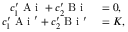<formula> <loc_0><loc_0><loc_500><loc_500>\begin{array} { r l } { c _ { 1 } ^ { \prime } A i + c _ { 2 } ^ { \prime } B i } & = 0 , } \\ { c _ { 1 } ^ { \prime } A i ^ { \prime } + c _ { 2 } ^ { \prime } B i ^ { \prime } } & = K , } \end{array}</formula> 